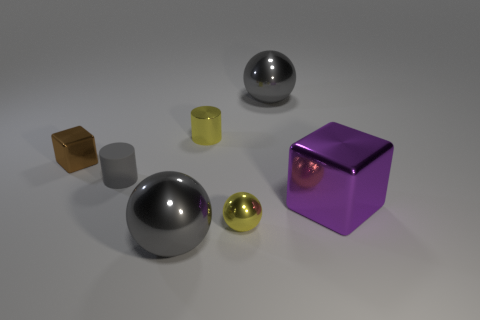There is a block that is the same size as the matte cylinder; what is its color? brown 